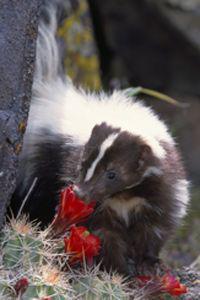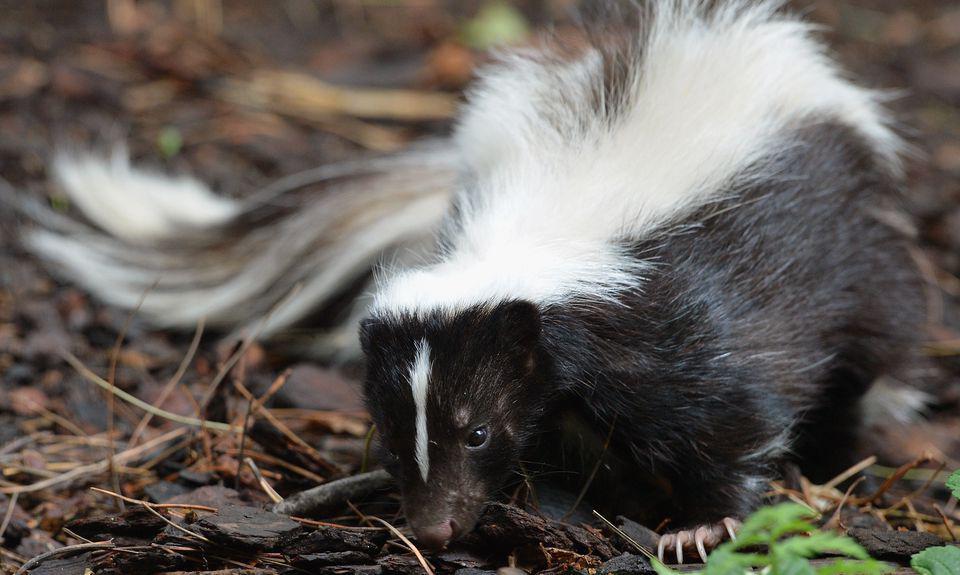The first image is the image on the left, the second image is the image on the right. Assess this claim about the two images: "The skunk in the right image is facing right.". Correct or not? Answer yes or no. No. 